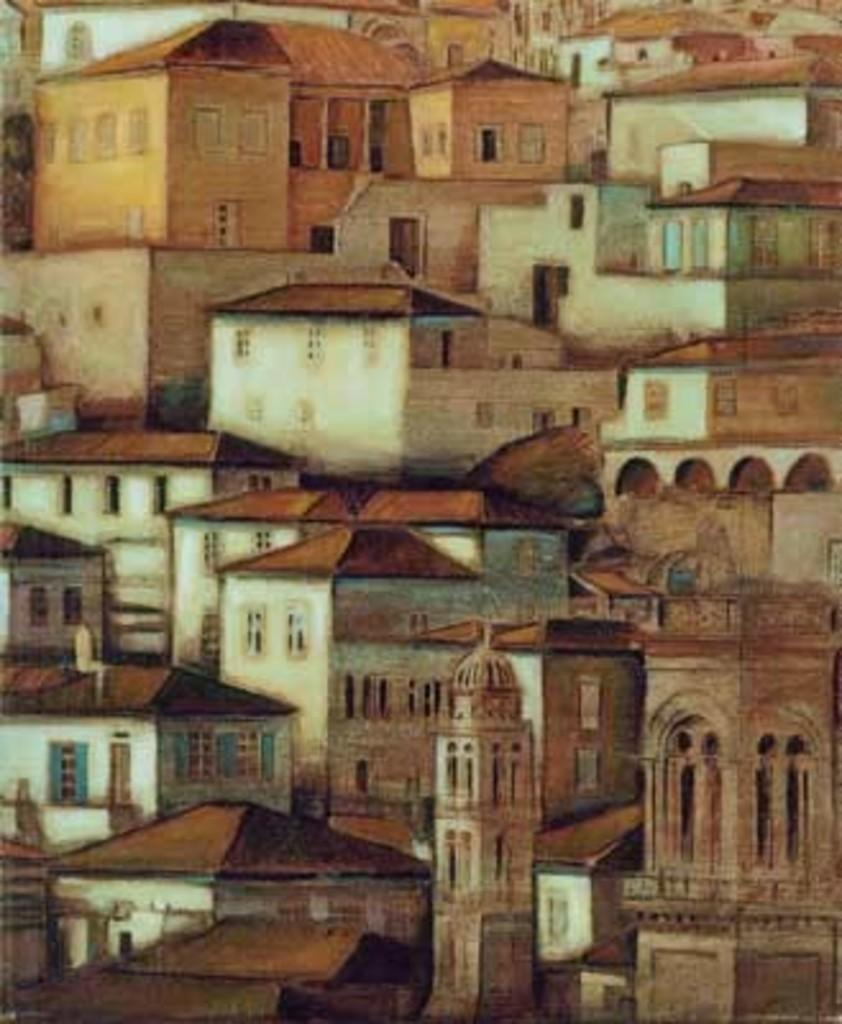What is the main subject of the image? There is a painting in the image. What else can be seen in the image besides the painting? There are buildings in the image. What type of school is depicted in the painting? There is no school depicted in the painting, as the image only shows a painting and buildings. What experience can be gained by observing the painting? The image does not provide information about any experiences that can be gained by observing the painting. 